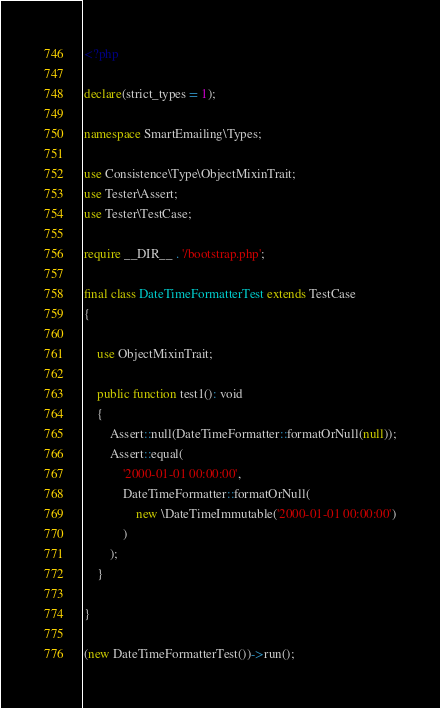Convert code to text. <code><loc_0><loc_0><loc_500><loc_500><_PHP_><?php

declare(strict_types = 1);

namespace SmartEmailing\Types;

use Consistence\Type\ObjectMixinTrait;
use Tester\Assert;
use Tester\TestCase;

require __DIR__ . '/bootstrap.php';

final class DateTimeFormatterTest extends TestCase
{

	use ObjectMixinTrait;

	public function test1(): void
	{
		Assert::null(DateTimeFormatter::formatOrNull(null));
		Assert::equal(
			'2000-01-01 00:00:00',
			DateTimeFormatter::formatOrNull(
				new \DateTimeImmutable('2000-01-01 00:00:00')
			)
		);
	}

}

(new DateTimeFormatterTest())->run();
</code> 